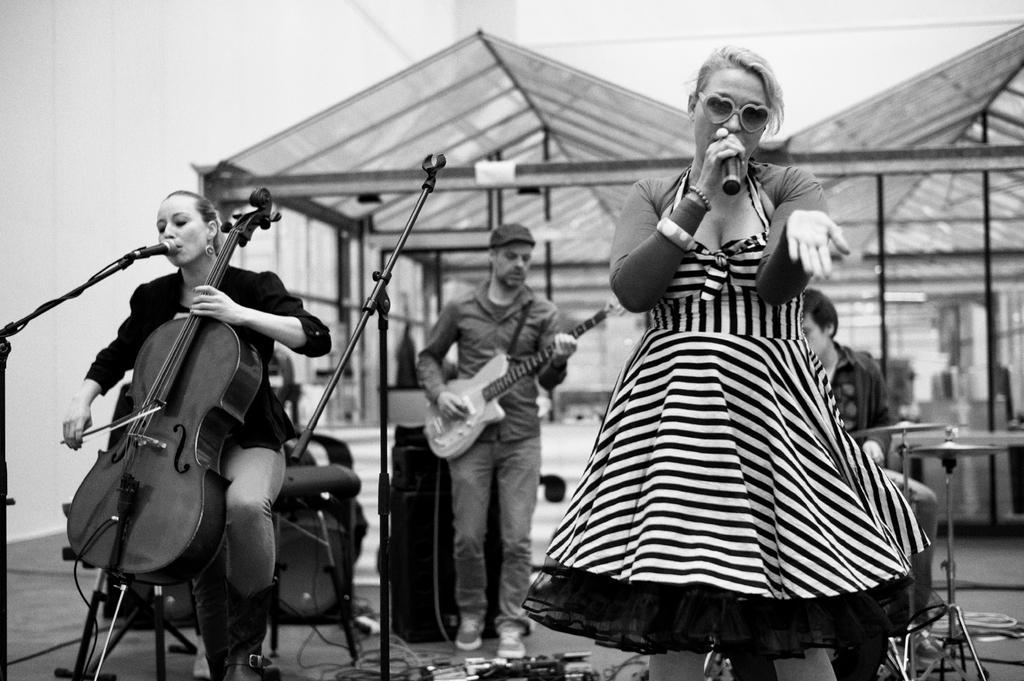Describe this image in one or two sentences. In this picture we can see three persons standing on the floor. They are playing guitars and she is holding a mike with her hand. On the background there is a shed. And this is wall. 